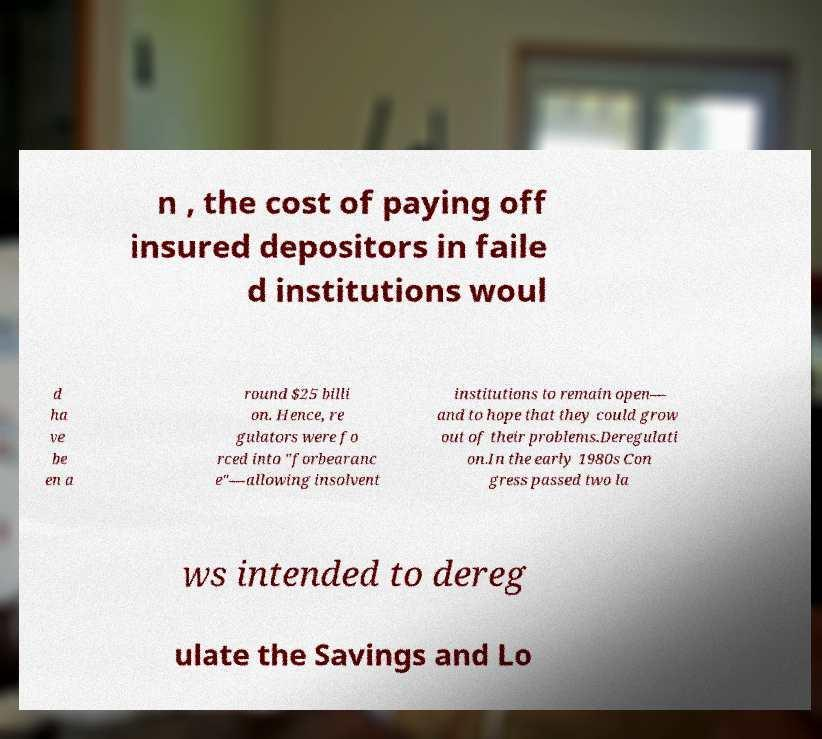What messages or text are displayed in this image? I need them in a readable, typed format. n , the cost of paying off insured depositors in faile d institutions woul d ha ve be en a round $25 billi on. Hence, re gulators were fo rced into "forbearanc e"—allowing insolvent institutions to remain open— and to hope that they could grow out of their problems.Deregulati on.In the early 1980s Con gress passed two la ws intended to dereg ulate the Savings and Lo 